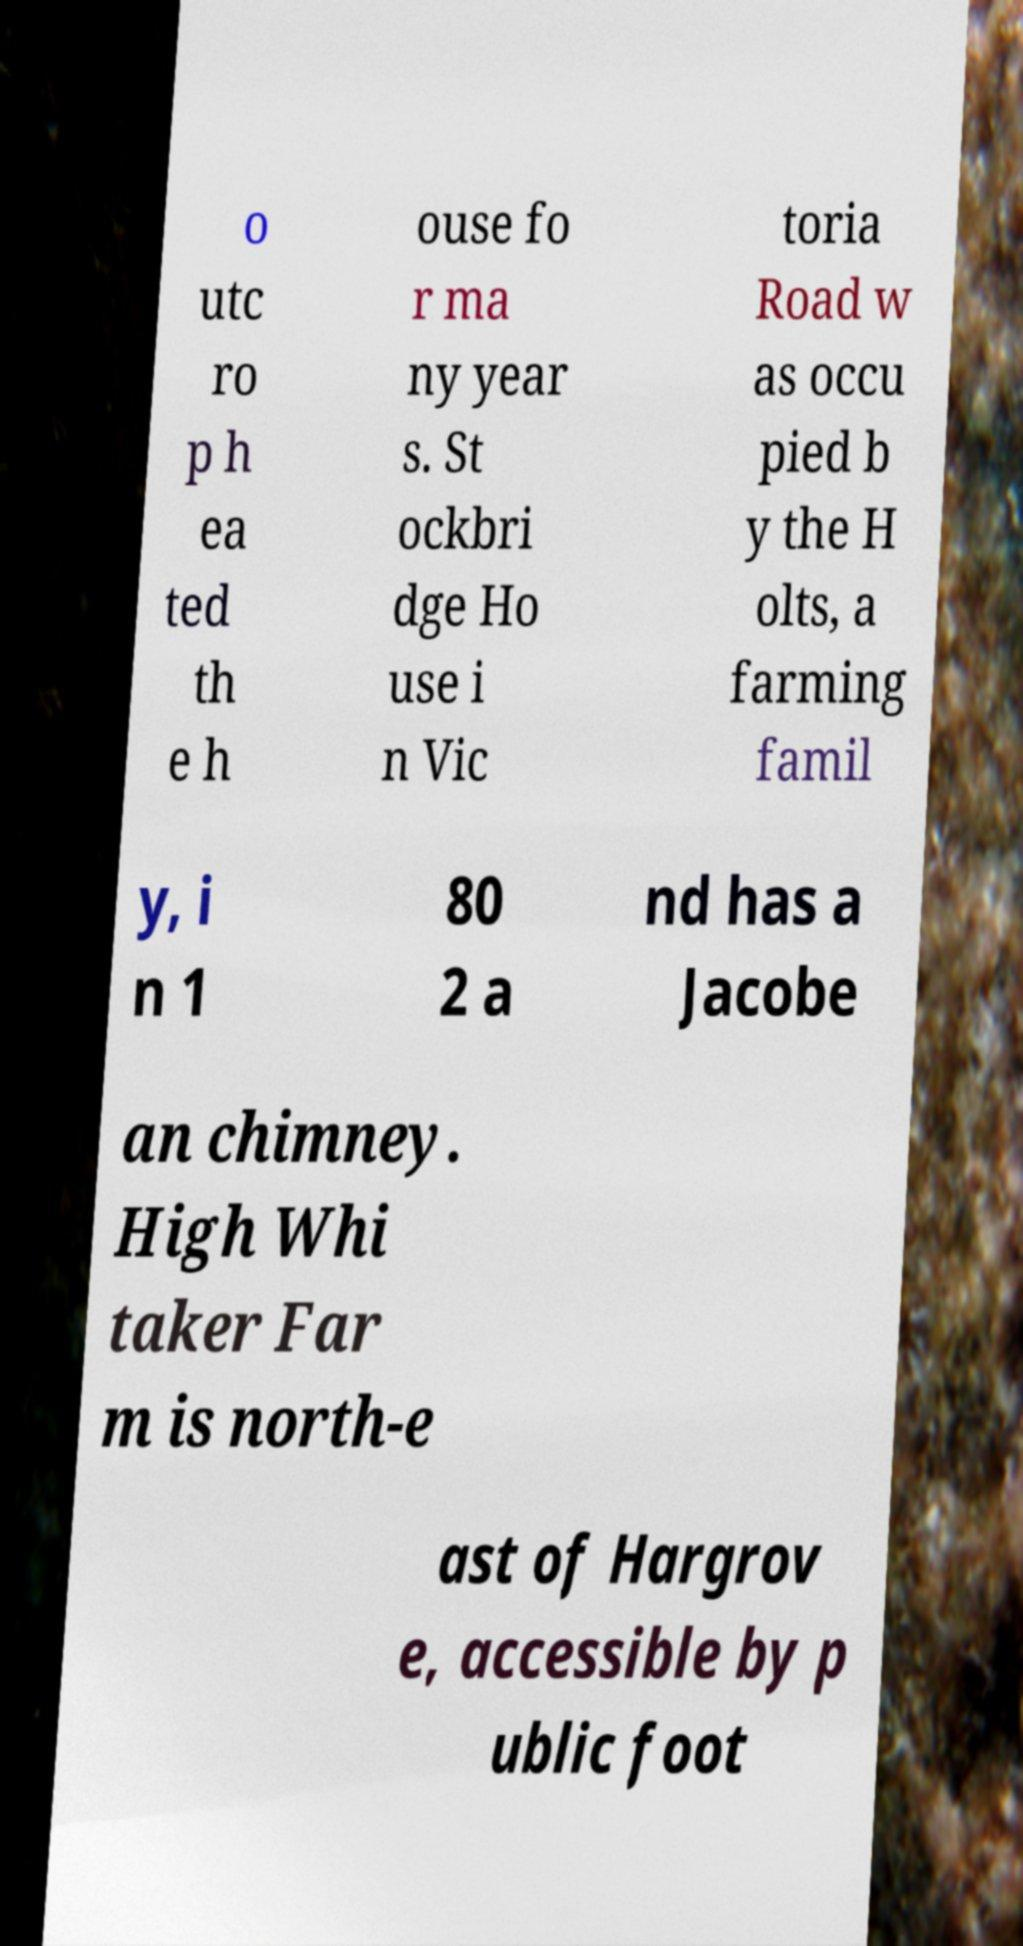Could you extract and type out the text from this image? o utc ro p h ea ted th e h ouse fo r ma ny year s. St ockbri dge Ho use i n Vic toria Road w as occu pied b y the H olts, a farming famil y, i n 1 80 2 a nd has a Jacobe an chimney. High Whi taker Far m is north-e ast of Hargrov e, accessible by p ublic foot 